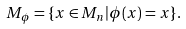Convert formula to latex. <formula><loc_0><loc_0><loc_500><loc_500>M _ { \phi } = \{ x \in M _ { n } | \phi ( x ) = x \} .</formula> 